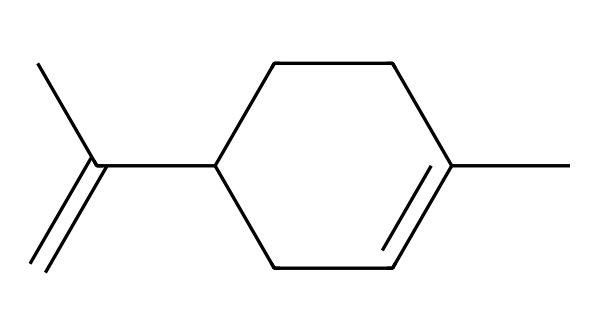How many carbon atoms are present in limonene? The SMILES notation shows 'C' as the symbol for carbon. By counting all the 'C' symbols in the structure, we find there are 10 carbon atoms.
Answer: 10 What functional group is present in limonene? Looking at the chemical structure, limonene contains a double bond indicated by 'C=C'. As there are no other explicitly indicated functional groups like alcohols or esters, we classify limonene mainly as an alkene due to the presence of this double bond.
Answer: alkene What is the degree of unsaturation in limonene? The formula for calculating the degree of unsaturation (DU) is DU = (1 + 2C + N - H - X)/2, where C = number of carbons, N = number of nitrogens, H = number of hydrogens, and X = number of halogens. For limonene, we have 10 carbons, 0 nitrogens, 16 hydrogens, and 0 halogens, resulting in a degree of unsaturation of 1.
Answer: 1 Which isomer of limonene is typically found in citrus fruits, R- or S-limonene? R-limonene is the predominant isomer found in citrus fruits, contributing to their distinctive aroma.
Answer: R-limonene What sensory perception is primarily associated with limonene? Limonene is primarily associated with a citrus scent, as it is commonly found in the peel of citrus fruits like lemons and oranges, which produce a fresh, sweet aroma.
Answer: citrus scent How many hydrogen atoms are in the limonene molecule? From the SMILES notation and its structural analysis, limonene has 16 hydrogen atoms. We arrive at this by considering the total count from the structure, confirming that it satisfies carbon's tetravalency and the double bond present.
Answer: 16 In what industries is limonene commonly used? Limonene is widely utilized in the fragrance industry, natural cleaning products, and as a solvent, due to its pleasant scent and biodegradable properties.
Answer: fragrance industry 